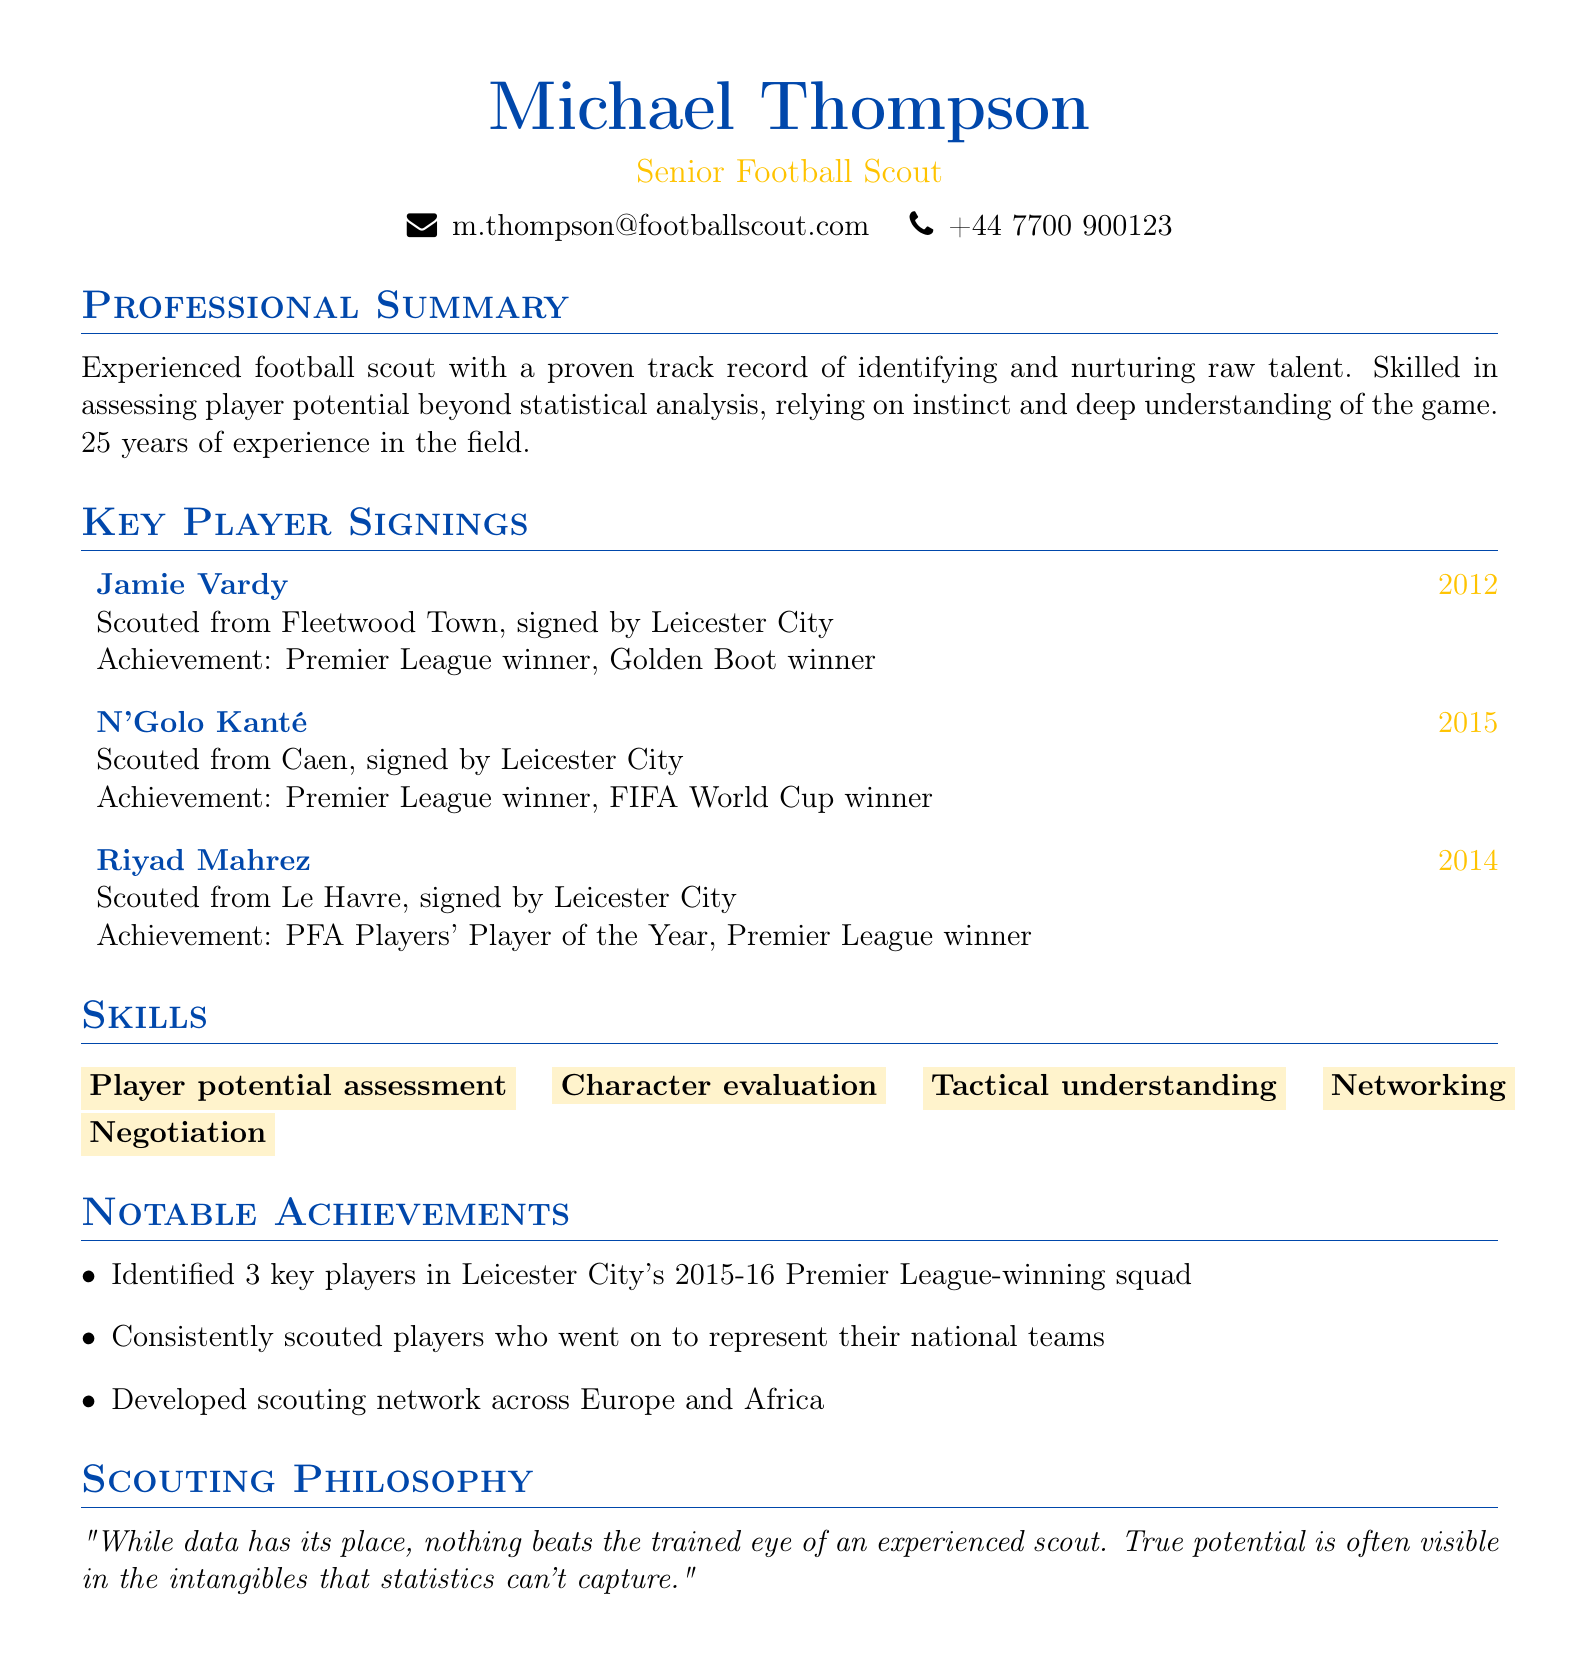what is the name of the scout? The scout's name is listed prominently at the top of the document.
Answer: Michael Thompson how many years of experience does the scout have? The document states the scout has a specific number of years in the field.
Answer: 25 which club signed Jamie Vardy? The document lists the club associated with Jamie Vardy's signing.
Answer: Leicester City what achievement is associated with N'Golo Kanté? The document lists specific accomplishments related to Kanté's career after being scouted.
Answer: Premier League winner, FIFA World Cup winner in what year was Riyad Mahrez signed? The document specifies the year Riyad Mahrez was signed.
Answer: 2014 how many key players did the scout identify in Leicester City's 2015-16 Premier League-winning squad? The document details a notable achievement related to key player identification.
Answer: 3 what is the scouting philosophy mentioned? The document includes a statement reflecting the scout's perspective on data versus experience.
Answer: "While data has its place, nothing beats the trained eye of an experienced scout. True potential is often visible in the intangibles that statistics can't capture." which skill is emphasized as part of the scout's abilities? The document lists various skills, focusing on those relevant to scouting.
Answer: Player potential assessment what is the email address of the scout? The document provides contact information including an email address.
Answer: m.thompson@footballscout.com 